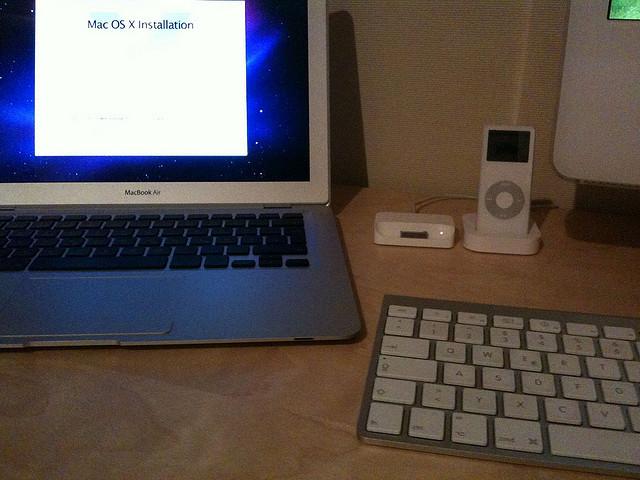Is software being installed?
Concise answer only. Yes. What device is in the upper right?
Write a very short answer. Ipod. What is on the bottom right?
Answer briefly. Keyboard. Is Bill Gates likely to buy this computer?
Quick response, please. No. What type of computer is in the photo?
Quick response, please. Laptop. Does the computer screen show the Mozilla Firefox logo on it?
Be succinct. No. How much money does this person make when working with this computer?
Be succinct. Unknown. What does the computer screen say?
Keep it brief. Mac os x installation. Is there a full keyboard in this image?
Give a very brief answer. No. Is this a Toshiba computer?
Quick response, please. No. 